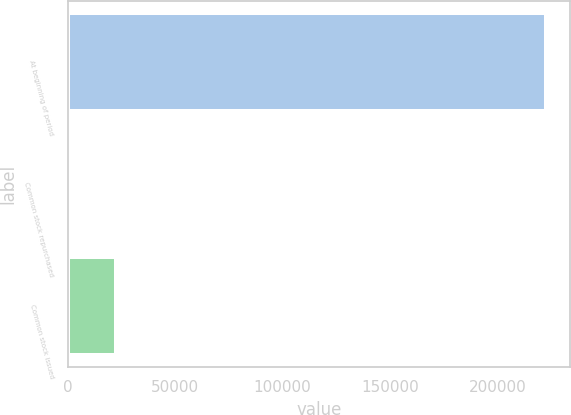Convert chart. <chart><loc_0><loc_0><loc_500><loc_500><bar_chart><fcel>At beginning of period<fcel>Common stock repurchased<fcel>Common stock issued<nl><fcel>222783<fcel>318<fcel>22564.5<nl></chart> 